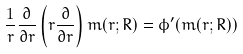Convert formula to latex. <formula><loc_0><loc_0><loc_500><loc_500>\frac { 1 } { r } \frac { \partial } { \partial r } \left ( r \frac { \partial } { \partial r } \right ) m ( r ; R ) = \phi ^ { \prime } ( m ( r ; R ) )</formula> 